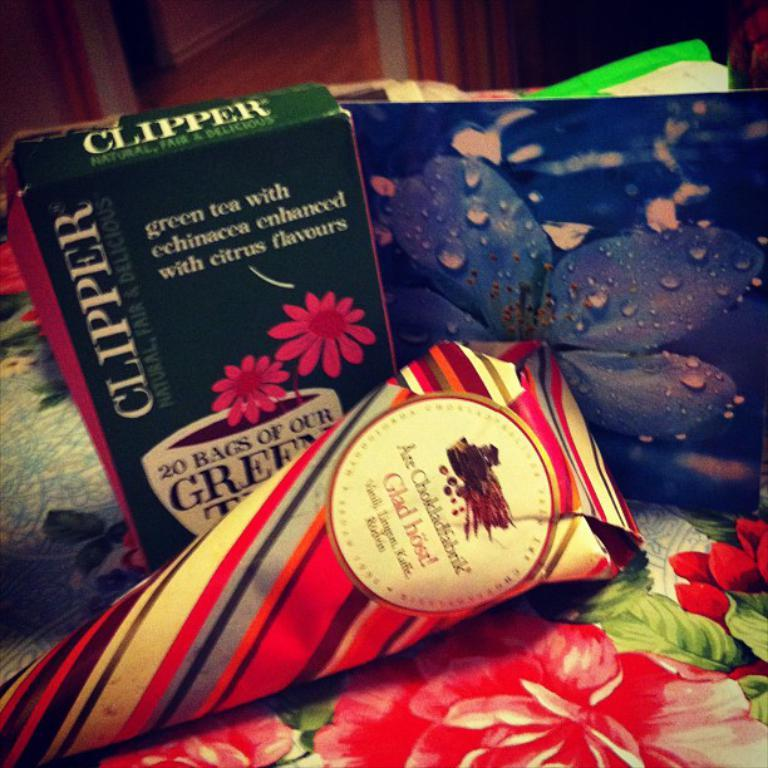<image>
Relay a brief, clear account of the picture shown. a box of Clipper green tea sits on a table next to a picture of a blue flower 